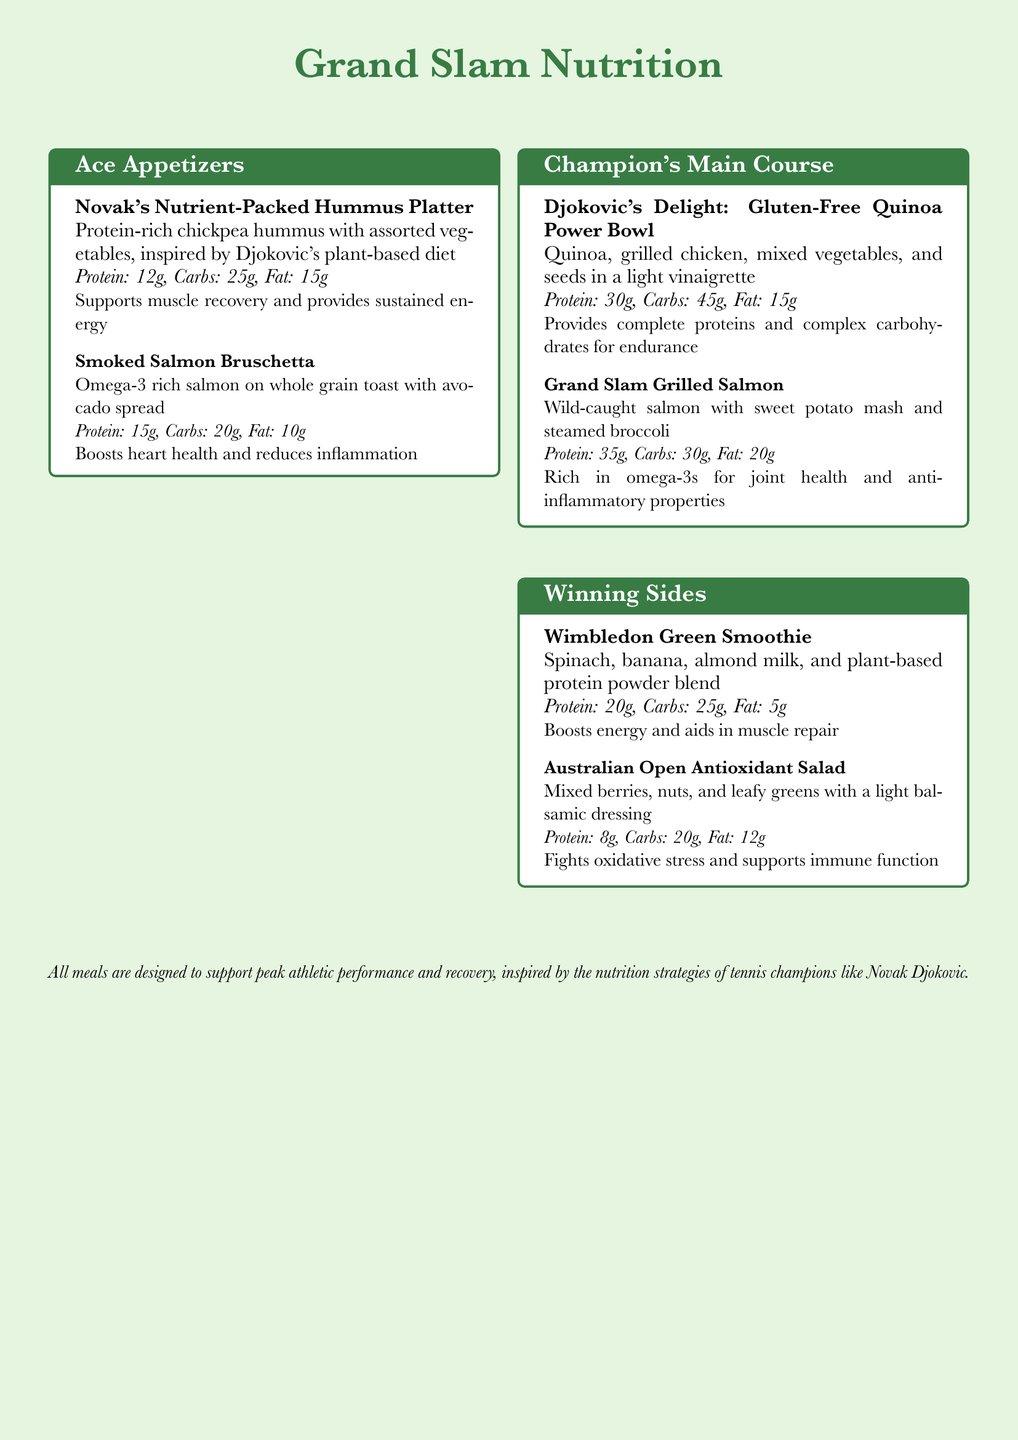What is the protein content in Novak's Nutrient-Packed Hummus Platter? The protein content is listed in the nutrition information for the dish, which specifies 12g of protein.
Answer: 12g What is the main protein source in Djokovic's Delight? The dish description mentions grilled chicken as the primary protein source.
Answer: Grilled chicken How many grams of protein does Grand Slam Grilled Salmon contain? The nutritional information specifies the protein content for this dish at 35g.
Answer: 35g What is the total fat content in the Australian Open Antioxidant Salad? The nutrition information for the salad indicates a total fat content of 12g.
Answer: 12g Which dish is inspired by Djokovic's plant-based diet? The description explicitly states that Novak's Nutrient-Packed Hummus Platter is inspired by his diet.
Answer: Novak's Nutrient-Packed Hummus Platter What type of milk is used in the Wimbledon Green Smoothie? The smoothie description mentions almond milk as an ingredient.
Answer: Almond milk How many grams of carbs are in the Grand Slam Grilled Salmon? The document lists the carb content for this dish, which is 30g.
Answer: 30g What beneficial properties does the Smoked Salmon Bruschetta provide? The dish overview mentions boosting heart health and reducing inflammation as its benefits.
Answer: Boosts heart health and reduces inflammation Which ingredient in the Wimbledon Green Smoothie is a source of protein? The smoothie description indicates that it contains plant-based protein powder.
Answer: Plant-based protein powder 